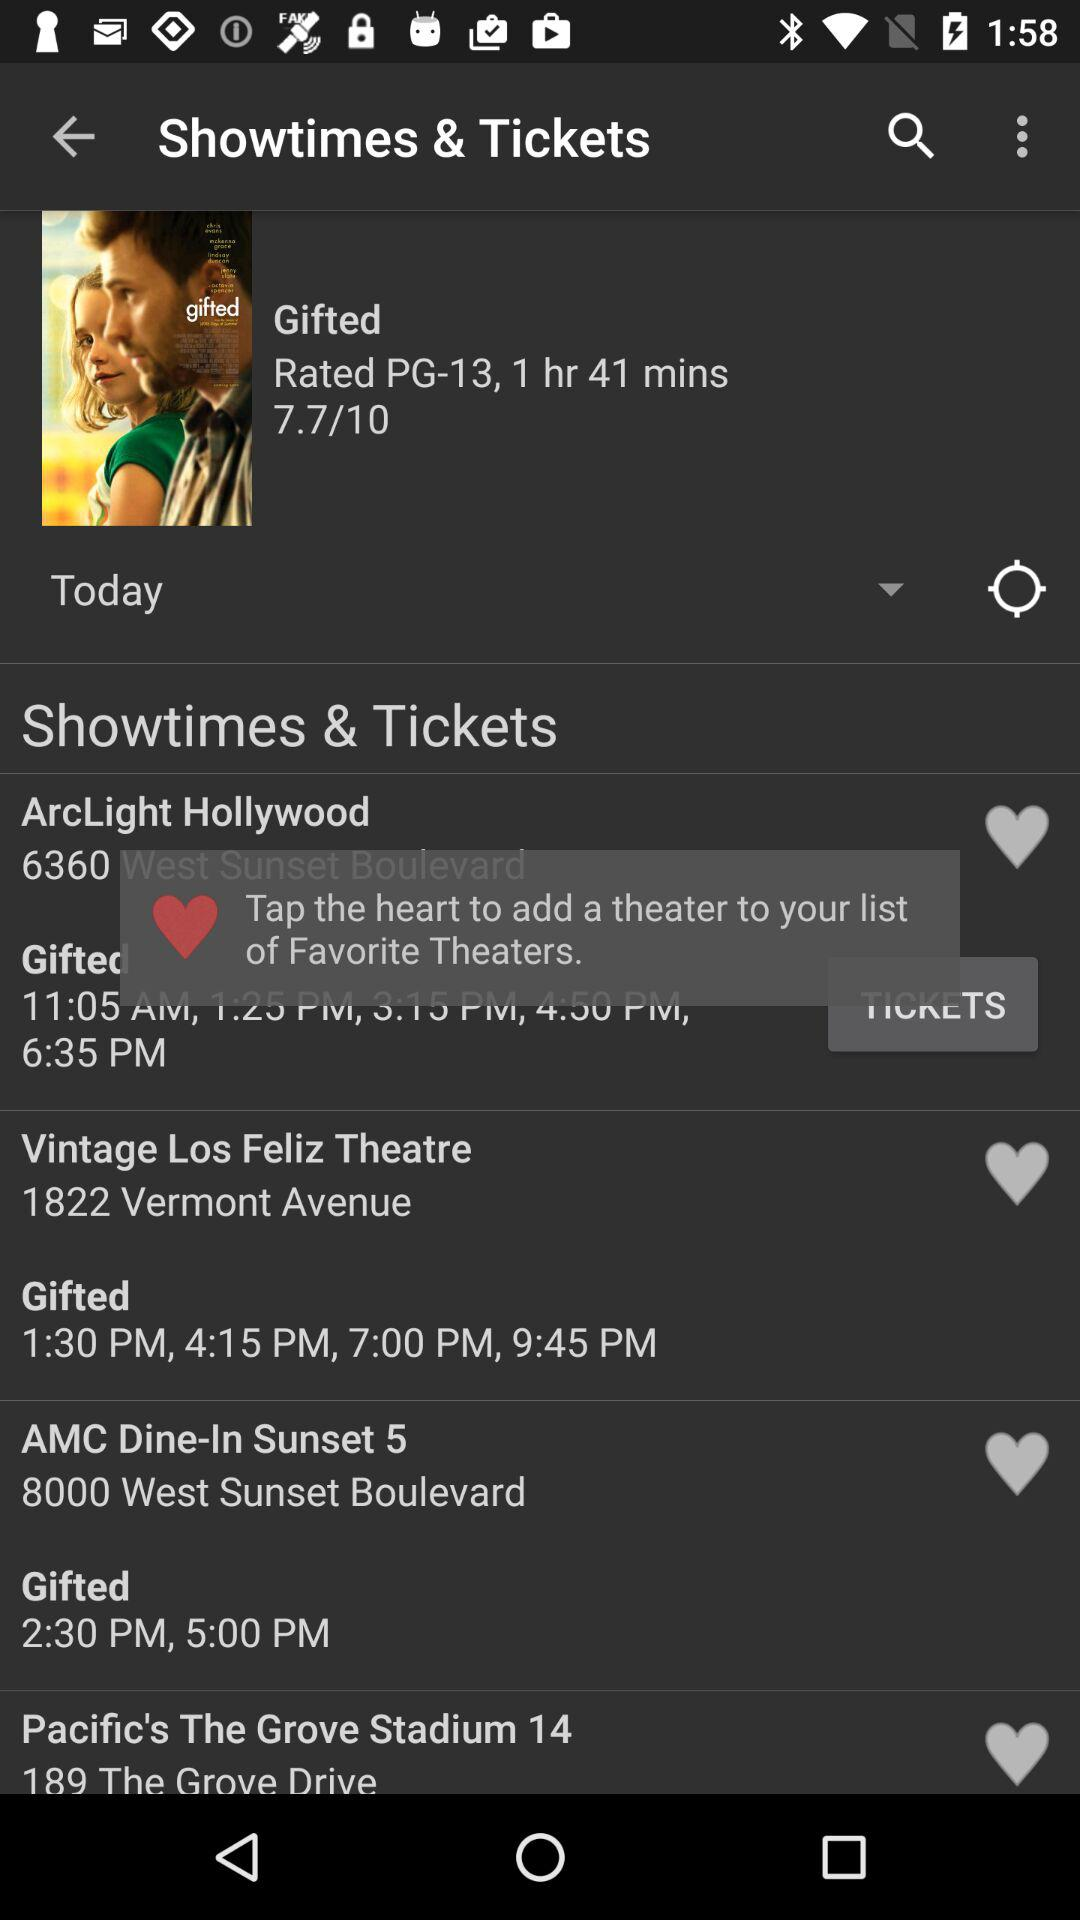What is the age limit for the movie?
When the provided information is insufficient, respond with <no answer>. <no answer> 